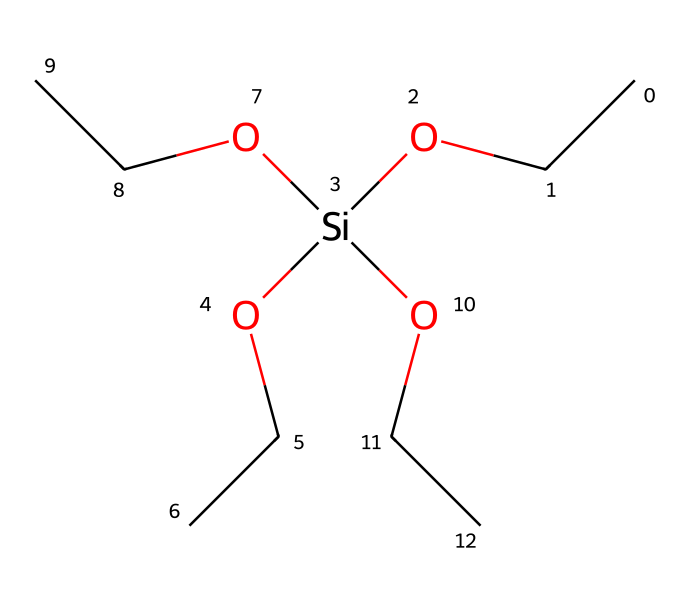What is the central atom in this silane compound? The silane compound contains silicon (Si) as the central atom, which can be identified as it is bonded to several hydrocarbon groups (ethoxy groups) and is located at the core of the structure.
Answer: silicon How many ethoxy (OCC) groups are present in this molecule? The structure contains three ethoxy groups, as indicated by the repeating pattern of the "OCC" that branches off from the silicon atom. Each "OCC" represents one ethoxy group.
Answer: three What is the total number of oxygen atoms in this chemical structure? By counting the oxygen atoms in the structure, there are four oxygen atoms: one bonded directly to silicon and three from each ethoxy group.
Answer: four What type of silane is represented by this chemical? Given the presence of multiple ethoxy groups and a silicon atom, this molecule is categorized as a trialkoxysilane because it has three alkoxy (ethoxy) groups attached to the silicon.
Answer: trialkoxysilane What property does the presence of silane in windshield treatments enhance? The inclusion of silane compounds in windshield treatments is known to enhance hydrophobic properties, allowing water to bead off the glass surface and thus improving visibility during rain.
Answer: hydrophobic How many total hydrogen atoms can be counted in this silane? By analyzing the structure, the count reveals that there are 18 hydrogen atoms, deriving from the ethoxy groups and the hydrogen atoms associated with the silicon.
Answer: eighteen 